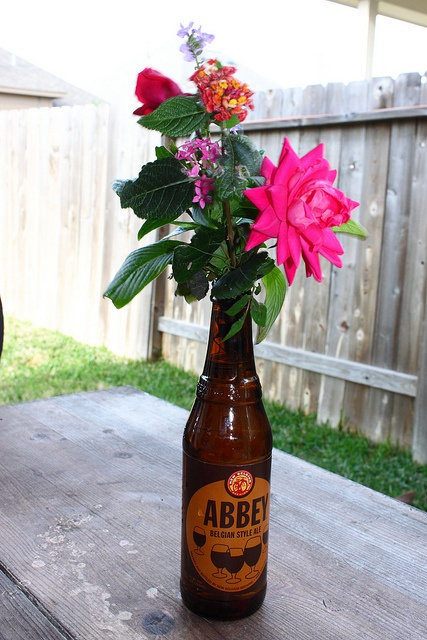Describe the objects in this image and their specific colors. I can see potted plant in white, black, maroon, and darkgreen tones, bottle in white, black, maroon, and brown tones, and vase in white, black, maroon, and brown tones in this image. 